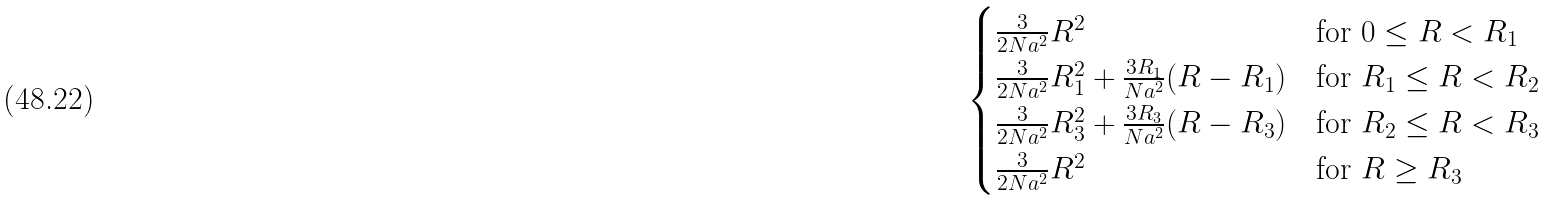<formula> <loc_0><loc_0><loc_500><loc_500>\begin{cases} \frac { 3 } { 2 N a ^ { 2 } } R ^ { 2 } & \text {for $0 \leq R < R_{1}$} \\ \frac { 3 } { 2 N a ^ { 2 } } R _ { 1 } ^ { 2 } + \frac { 3 R _ { 1 } } { N a ^ { 2 } } ( R - R _ { 1 } ) & \text {for $R_{1} \leq R < R_{2}$} \\ \frac { 3 } { 2 N a ^ { 2 } } R _ { 3 } ^ { 2 } + \frac { 3 R _ { 3 } } { N a ^ { 2 } } ( R - R _ { 3 } ) & \text {for $R_{2} \leq R < R_{3}$} \\ \frac { 3 } { 2 N a ^ { 2 } } R ^ { 2 } & \text {for $R \geq R_{3}$} \end{cases}</formula> 